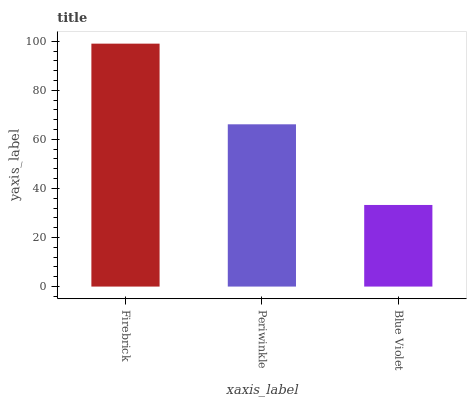Is Periwinkle the minimum?
Answer yes or no. No. Is Periwinkle the maximum?
Answer yes or no. No. Is Firebrick greater than Periwinkle?
Answer yes or no. Yes. Is Periwinkle less than Firebrick?
Answer yes or no. Yes. Is Periwinkle greater than Firebrick?
Answer yes or no. No. Is Firebrick less than Periwinkle?
Answer yes or no. No. Is Periwinkle the high median?
Answer yes or no. Yes. Is Periwinkle the low median?
Answer yes or no. Yes. Is Blue Violet the high median?
Answer yes or no. No. Is Firebrick the low median?
Answer yes or no. No. 